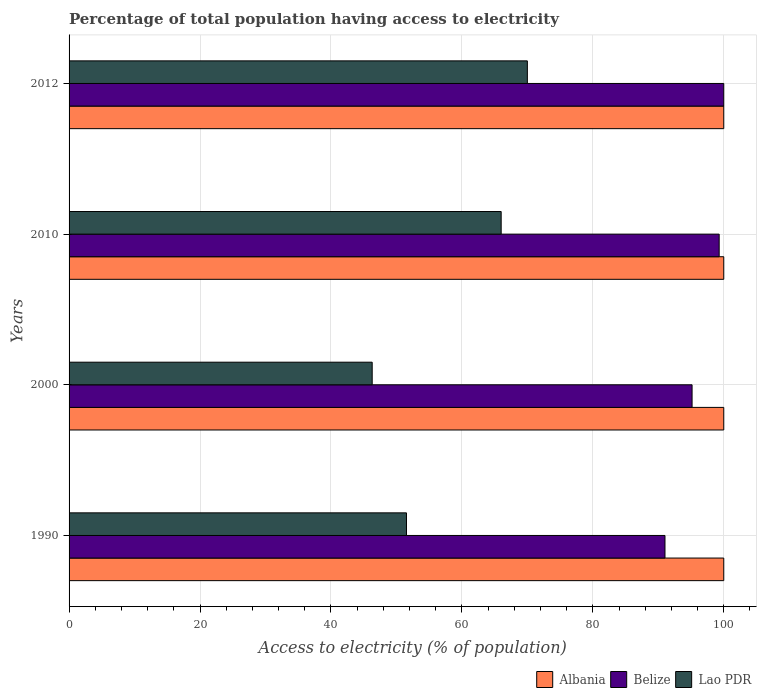How many groups of bars are there?
Ensure brevity in your answer.  4. Are the number of bars per tick equal to the number of legend labels?
Offer a terse response. Yes. How many bars are there on the 1st tick from the top?
Ensure brevity in your answer.  3. How many bars are there on the 1st tick from the bottom?
Give a very brief answer. 3. In how many cases, is the number of bars for a given year not equal to the number of legend labels?
Keep it short and to the point. 0. What is the percentage of population that have access to electricity in Lao PDR in 1990?
Your answer should be very brief. 51.54. Across all years, what is the maximum percentage of population that have access to electricity in Albania?
Ensure brevity in your answer.  100. Across all years, what is the minimum percentage of population that have access to electricity in Albania?
Make the answer very short. 100. In which year was the percentage of population that have access to electricity in Lao PDR maximum?
Provide a succinct answer. 2012. In which year was the percentage of population that have access to electricity in Albania minimum?
Offer a terse response. 1990. What is the total percentage of population that have access to electricity in Albania in the graph?
Provide a succinct answer. 400. What is the difference between the percentage of population that have access to electricity in Lao PDR in 2010 and the percentage of population that have access to electricity in Albania in 2000?
Your answer should be very brief. -34. What is the average percentage of population that have access to electricity in Belize per year?
Your answer should be very brief. 96.37. In the year 2012, what is the difference between the percentage of population that have access to electricity in Lao PDR and percentage of population that have access to electricity in Albania?
Give a very brief answer. -30. In how many years, is the percentage of population that have access to electricity in Lao PDR greater than 48 %?
Your response must be concise. 3. What is the ratio of the percentage of population that have access to electricity in Belize in 1990 to that in 2000?
Ensure brevity in your answer.  0.96. What is the difference between the highest and the second highest percentage of population that have access to electricity in Belize?
Ensure brevity in your answer.  0.7. What is the difference between the highest and the lowest percentage of population that have access to electricity in Belize?
Provide a short and direct response. 8.98. In how many years, is the percentage of population that have access to electricity in Albania greater than the average percentage of population that have access to electricity in Albania taken over all years?
Provide a short and direct response. 0. Is the sum of the percentage of population that have access to electricity in Lao PDR in 2010 and 2012 greater than the maximum percentage of population that have access to electricity in Albania across all years?
Your answer should be compact. Yes. What does the 1st bar from the top in 2012 represents?
Your response must be concise. Lao PDR. What does the 1st bar from the bottom in 2010 represents?
Your response must be concise. Albania. Is it the case that in every year, the sum of the percentage of population that have access to electricity in Albania and percentage of population that have access to electricity in Lao PDR is greater than the percentage of population that have access to electricity in Belize?
Provide a short and direct response. Yes. How many bars are there?
Your response must be concise. 12. How many years are there in the graph?
Give a very brief answer. 4. What is the difference between two consecutive major ticks on the X-axis?
Your response must be concise. 20. Does the graph contain grids?
Provide a succinct answer. Yes. Where does the legend appear in the graph?
Offer a terse response. Bottom right. How many legend labels are there?
Ensure brevity in your answer.  3. How are the legend labels stacked?
Your answer should be very brief. Horizontal. What is the title of the graph?
Make the answer very short. Percentage of total population having access to electricity. Does "Suriname" appear as one of the legend labels in the graph?
Offer a very short reply. No. What is the label or title of the X-axis?
Give a very brief answer. Access to electricity (% of population). What is the Access to electricity (% of population) in Belize in 1990?
Offer a terse response. 91.02. What is the Access to electricity (% of population) in Lao PDR in 1990?
Make the answer very short. 51.54. What is the Access to electricity (% of population) of Albania in 2000?
Offer a very short reply. 100. What is the Access to electricity (% of population) in Belize in 2000?
Offer a terse response. 95.16. What is the Access to electricity (% of population) of Lao PDR in 2000?
Your answer should be very brief. 46.3. What is the Access to electricity (% of population) in Albania in 2010?
Your answer should be very brief. 100. What is the Access to electricity (% of population) of Belize in 2010?
Keep it short and to the point. 99.3. What is the Access to electricity (% of population) in Lao PDR in 2010?
Your answer should be compact. 66. What is the Access to electricity (% of population) of Albania in 2012?
Give a very brief answer. 100. What is the Access to electricity (% of population) of Belize in 2012?
Make the answer very short. 100. Across all years, what is the maximum Access to electricity (% of population) of Albania?
Provide a short and direct response. 100. Across all years, what is the maximum Access to electricity (% of population) of Belize?
Keep it short and to the point. 100. Across all years, what is the maximum Access to electricity (% of population) in Lao PDR?
Provide a short and direct response. 70. Across all years, what is the minimum Access to electricity (% of population) in Belize?
Ensure brevity in your answer.  91.02. Across all years, what is the minimum Access to electricity (% of population) of Lao PDR?
Keep it short and to the point. 46.3. What is the total Access to electricity (% of population) of Albania in the graph?
Ensure brevity in your answer.  400. What is the total Access to electricity (% of population) in Belize in the graph?
Ensure brevity in your answer.  385.48. What is the total Access to electricity (% of population) of Lao PDR in the graph?
Your response must be concise. 233.84. What is the difference between the Access to electricity (% of population) in Belize in 1990 and that in 2000?
Provide a short and direct response. -4.14. What is the difference between the Access to electricity (% of population) of Lao PDR in 1990 and that in 2000?
Provide a short and direct response. 5.24. What is the difference between the Access to electricity (% of population) in Belize in 1990 and that in 2010?
Make the answer very short. -8.28. What is the difference between the Access to electricity (% of population) of Lao PDR in 1990 and that in 2010?
Offer a terse response. -14.46. What is the difference between the Access to electricity (% of population) in Albania in 1990 and that in 2012?
Your answer should be compact. 0. What is the difference between the Access to electricity (% of population) of Belize in 1990 and that in 2012?
Offer a very short reply. -8.98. What is the difference between the Access to electricity (% of population) in Lao PDR in 1990 and that in 2012?
Provide a succinct answer. -18.46. What is the difference between the Access to electricity (% of population) in Albania in 2000 and that in 2010?
Give a very brief answer. 0. What is the difference between the Access to electricity (% of population) in Belize in 2000 and that in 2010?
Make the answer very short. -4.14. What is the difference between the Access to electricity (% of population) in Lao PDR in 2000 and that in 2010?
Ensure brevity in your answer.  -19.7. What is the difference between the Access to electricity (% of population) in Albania in 2000 and that in 2012?
Give a very brief answer. 0. What is the difference between the Access to electricity (% of population) in Belize in 2000 and that in 2012?
Provide a succinct answer. -4.84. What is the difference between the Access to electricity (% of population) in Lao PDR in 2000 and that in 2012?
Offer a terse response. -23.7. What is the difference between the Access to electricity (% of population) of Belize in 2010 and that in 2012?
Ensure brevity in your answer.  -0.7. What is the difference between the Access to electricity (% of population) of Albania in 1990 and the Access to electricity (% of population) of Belize in 2000?
Make the answer very short. 4.84. What is the difference between the Access to electricity (% of population) in Albania in 1990 and the Access to electricity (% of population) in Lao PDR in 2000?
Your answer should be compact. 53.7. What is the difference between the Access to electricity (% of population) of Belize in 1990 and the Access to electricity (% of population) of Lao PDR in 2000?
Your answer should be very brief. 44.72. What is the difference between the Access to electricity (% of population) in Belize in 1990 and the Access to electricity (% of population) in Lao PDR in 2010?
Ensure brevity in your answer.  25.02. What is the difference between the Access to electricity (% of population) in Albania in 1990 and the Access to electricity (% of population) in Lao PDR in 2012?
Provide a succinct answer. 30. What is the difference between the Access to electricity (% of population) in Belize in 1990 and the Access to electricity (% of population) in Lao PDR in 2012?
Offer a terse response. 21.02. What is the difference between the Access to electricity (% of population) in Albania in 2000 and the Access to electricity (% of population) in Lao PDR in 2010?
Offer a very short reply. 34. What is the difference between the Access to electricity (% of population) in Belize in 2000 and the Access to electricity (% of population) in Lao PDR in 2010?
Keep it short and to the point. 29.16. What is the difference between the Access to electricity (% of population) of Albania in 2000 and the Access to electricity (% of population) of Belize in 2012?
Provide a succinct answer. 0. What is the difference between the Access to electricity (% of population) in Albania in 2000 and the Access to electricity (% of population) in Lao PDR in 2012?
Your answer should be compact. 30. What is the difference between the Access to electricity (% of population) of Belize in 2000 and the Access to electricity (% of population) of Lao PDR in 2012?
Make the answer very short. 25.16. What is the difference between the Access to electricity (% of population) in Albania in 2010 and the Access to electricity (% of population) in Belize in 2012?
Your answer should be compact. 0. What is the difference between the Access to electricity (% of population) in Albania in 2010 and the Access to electricity (% of population) in Lao PDR in 2012?
Your answer should be very brief. 30. What is the difference between the Access to electricity (% of population) in Belize in 2010 and the Access to electricity (% of population) in Lao PDR in 2012?
Your answer should be compact. 29.3. What is the average Access to electricity (% of population) of Belize per year?
Your answer should be very brief. 96.37. What is the average Access to electricity (% of population) in Lao PDR per year?
Make the answer very short. 58.46. In the year 1990, what is the difference between the Access to electricity (% of population) of Albania and Access to electricity (% of population) of Belize?
Provide a short and direct response. 8.98. In the year 1990, what is the difference between the Access to electricity (% of population) in Albania and Access to electricity (% of population) in Lao PDR?
Keep it short and to the point. 48.46. In the year 1990, what is the difference between the Access to electricity (% of population) of Belize and Access to electricity (% of population) of Lao PDR?
Make the answer very short. 39.48. In the year 2000, what is the difference between the Access to electricity (% of population) in Albania and Access to electricity (% of population) in Belize?
Ensure brevity in your answer.  4.84. In the year 2000, what is the difference between the Access to electricity (% of population) of Albania and Access to electricity (% of population) of Lao PDR?
Offer a terse response. 53.7. In the year 2000, what is the difference between the Access to electricity (% of population) in Belize and Access to electricity (% of population) in Lao PDR?
Make the answer very short. 48.86. In the year 2010, what is the difference between the Access to electricity (% of population) in Albania and Access to electricity (% of population) in Belize?
Your response must be concise. 0.7. In the year 2010, what is the difference between the Access to electricity (% of population) of Albania and Access to electricity (% of population) of Lao PDR?
Your answer should be compact. 34. In the year 2010, what is the difference between the Access to electricity (% of population) of Belize and Access to electricity (% of population) of Lao PDR?
Make the answer very short. 33.3. In the year 2012, what is the difference between the Access to electricity (% of population) in Albania and Access to electricity (% of population) in Belize?
Keep it short and to the point. 0. In the year 2012, what is the difference between the Access to electricity (% of population) in Albania and Access to electricity (% of population) in Lao PDR?
Give a very brief answer. 30. What is the ratio of the Access to electricity (% of population) of Belize in 1990 to that in 2000?
Offer a terse response. 0.96. What is the ratio of the Access to electricity (% of population) of Lao PDR in 1990 to that in 2000?
Offer a very short reply. 1.11. What is the ratio of the Access to electricity (% of population) in Belize in 1990 to that in 2010?
Give a very brief answer. 0.92. What is the ratio of the Access to electricity (% of population) in Lao PDR in 1990 to that in 2010?
Your answer should be very brief. 0.78. What is the ratio of the Access to electricity (% of population) in Belize in 1990 to that in 2012?
Your response must be concise. 0.91. What is the ratio of the Access to electricity (% of population) of Lao PDR in 1990 to that in 2012?
Provide a short and direct response. 0.74. What is the ratio of the Access to electricity (% of population) of Belize in 2000 to that in 2010?
Ensure brevity in your answer.  0.96. What is the ratio of the Access to electricity (% of population) in Lao PDR in 2000 to that in 2010?
Offer a very short reply. 0.7. What is the ratio of the Access to electricity (% of population) in Belize in 2000 to that in 2012?
Offer a terse response. 0.95. What is the ratio of the Access to electricity (% of population) of Lao PDR in 2000 to that in 2012?
Ensure brevity in your answer.  0.66. What is the ratio of the Access to electricity (% of population) of Lao PDR in 2010 to that in 2012?
Provide a succinct answer. 0.94. What is the difference between the highest and the second highest Access to electricity (% of population) in Belize?
Provide a succinct answer. 0.7. What is the difference between the highest and the lowest Access to electricity (% of population) in Belize?
Provide a succinct answer. 8.98. What is the difference between the highest and the lowest Access to electricity (% of population) in Lao PDR?
Your answer should be compact. 23.7. 